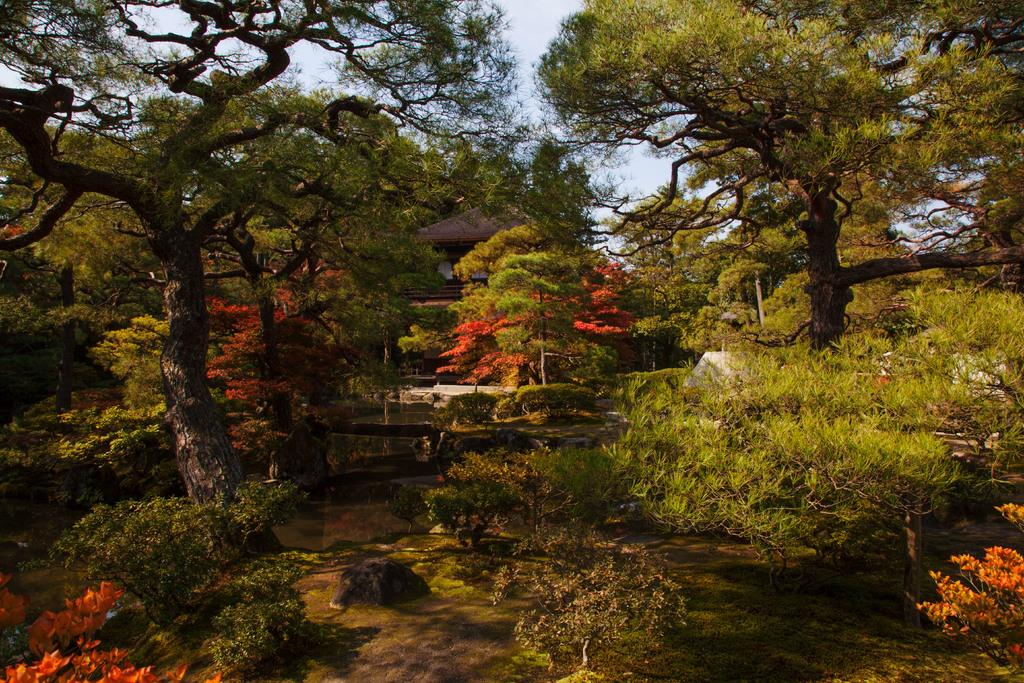What type of vegetation can be seen in the image? There are trees and plants in the image. What can be seen in the image besides vegetation? There is water visible in the image, as well as a house. What is visible in the background of the image? The sky is visible in the background of the image. What type of turkey can be seen swimming in the water in the image? There is no turkey present in the image; it only features trees, plants, water, a house, and the sky. 